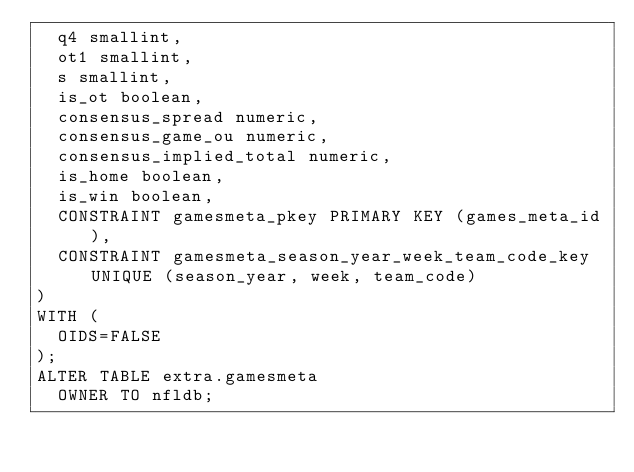Convert code to text. <code><loc_0><loc_0><loc_500><loc_500><_SQL_>  q4 smallint,
  ot1 smallint,
  s smallint,
  is_ot boolean,
  consensus_spread numeric,
  consensus_game_ou numeric,
  consensus_implied_total numeric,
  is_home boolean,
  is_win boolean,
  CONSTRAINT gamesmeta_pkey PRIMARY KEY (games_meta_id),
  CONSTRAINT gamesmeta_season_year_week_team_code_key UNIQUE (season_year, week, team_code)
)
WITH (
  OIDS=FALSE
);
ALTER TABLE extra.gamesmeta
  OWNER TO nfldb;
</code> 